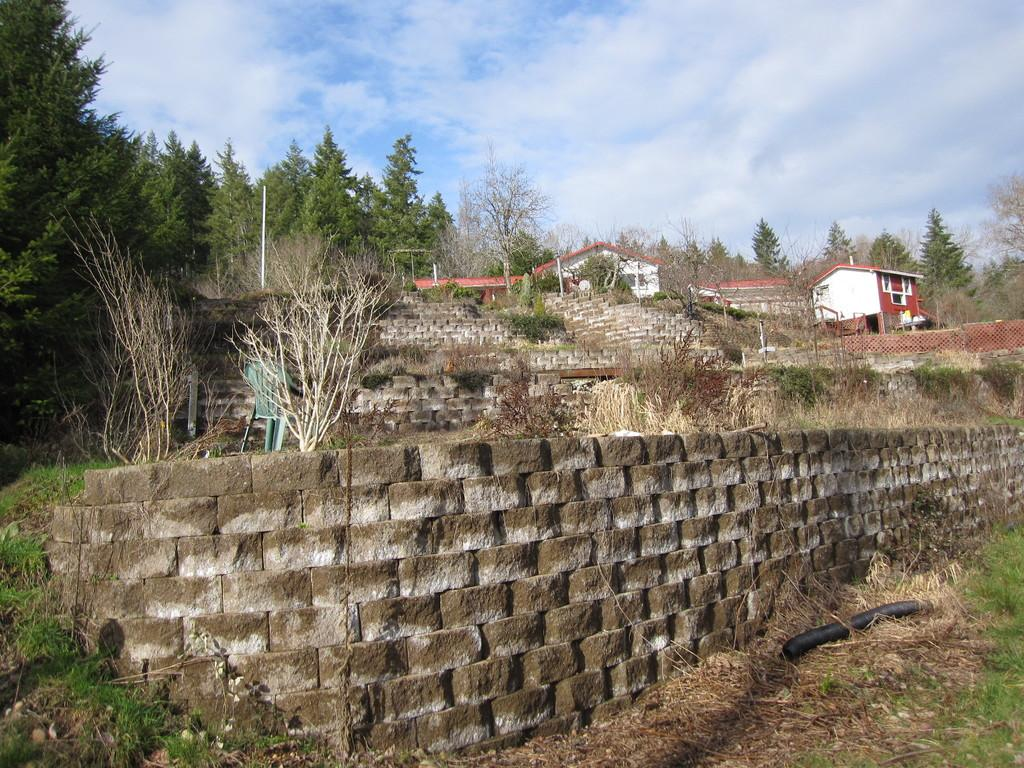What can be seen in the foreground of the image? There are shrubs, plants, and walls in the foreground of the image. What is located in the center of the image? There are houses and trees in the center of the image, along with walls. What is visible at the top of the image? The sky is visible at the top of the image. Can you tell me how many strangers are wearing masks in the image? There are no strangers or masks present in the image. What type of house is depicted in the image? The provided facts do not specify the type of house; only that there are houses in the center of the image. 